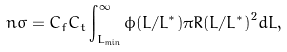Convert formula to latex. <formula><loc_0><loc_0><loc_500><loc_500>n \sigma = C _ { f } C _ { t } \int _ { L _ { \min } } ^ { \infty } \phi ( L / L ^ { * } ) \pi { R ( L / L ^ { * } ) } ^ { 2 } d L ,</formula> 